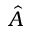Convert formula to latex. <formula><loc_0><loc_0><loc_500><loc_500>\hat { A }</formula> 